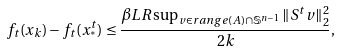Convert formula to latex. <formula><loc_0><loc_0><loc_500><loc_500>f _ { t } ( x _ { k } ) - f _ { t } ( x _ { ^ { * } } ^ { t } ) \leq \frac { \beta L R \sup _ { v \in r a n g e ( A ) \cap \mathbb { S } ^ { n - 1 } } \| S ^ { t } v \| _ { 2 } ^ { 2 } } { 2 k } ,</formula> 